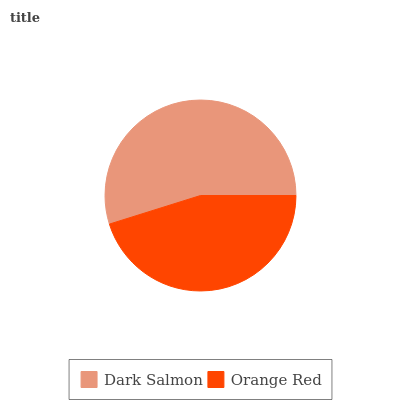Is Orange Red the minimum?
Answer yes or no. Yes. Is Dark Salmon the maximum?
Answer yes or no. Yes. Is Orange Red the maximum?
Answer yes or no. No. Is Dark Salmon greater than Orange Red?
Answer yes or no. Yes. Is Orange Red less than Dark Salmon?
Answer yes or no. Yes. Is Orange Red greater than Dark Salmon?
Answer yes or no. No. Is Dark Salmon less than Orange Red?
Answer yes or no. No. Is Dark Salmon the high median?
Answer yes or no. Yes. Is Orange Red the low median?
Answer yes or no. Yes. Is Orange Red the high median?
Answer yes or no. No. Is Dark Salmon the low median?
Answer yes or no. No. 